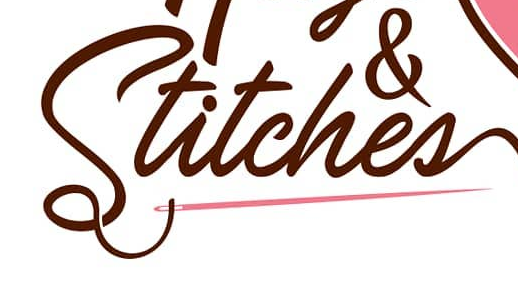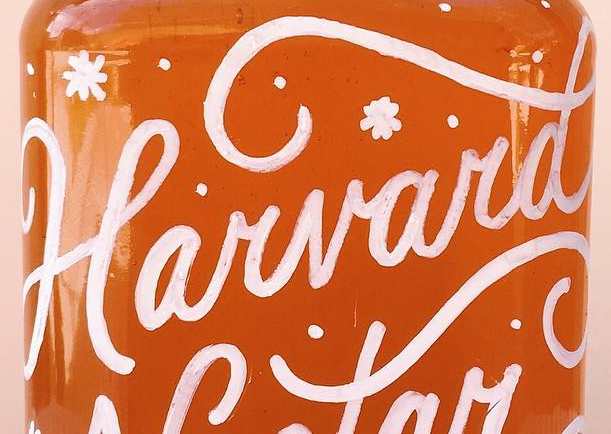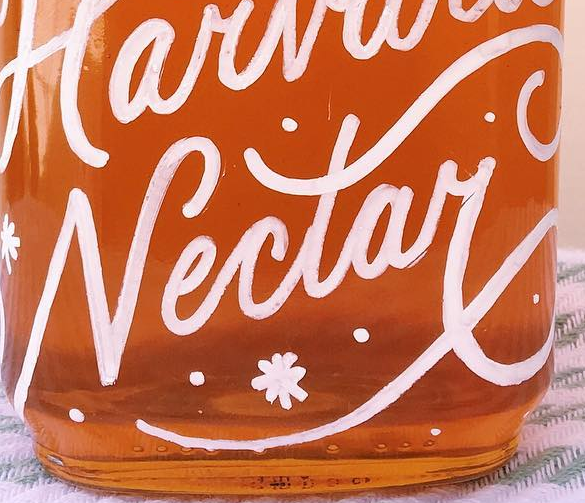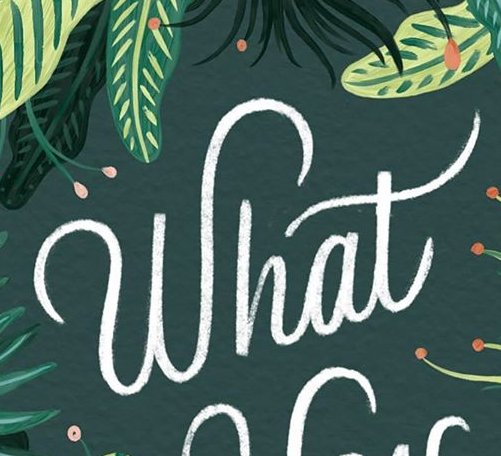Identify the words shown in these images in order, separated by a semicolon. Stitches; Harvard; Nectay; What 